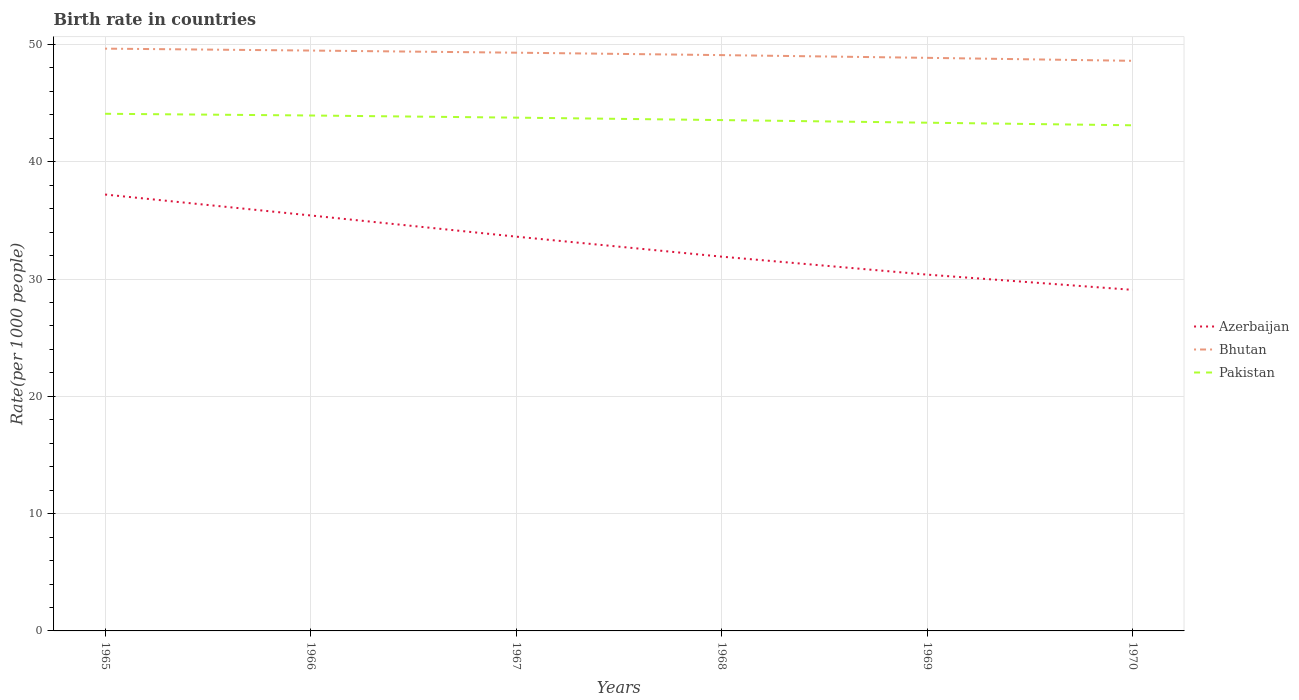Does the line corresponding to Azerbaijan intersect with the line corresponding to Bhutan?
Offer a terse response. No. Is the number of lines equal to the number of legend labels?
Make the answer very short. Yes. Across all years, what is the maximum birth rate in Bhutan?
Offer a very short reply. 48.6. What is the total birth rate in Pakistan in the graph?
Your answer should be very brief. 0.76. What is the difference between the highest and the second highest birth rate in Pakistan?
Ensure brevity in your answer.  0.98. Is the birth rate in Azerbaijan strictly greater than the birth rate in Pakistan over the years?
Provide a succinct answer. Yes. How many lines are there?
Your response must be concise. 3. Are the values on the major ticks of Y-axis written in scientific E-notation?
Your answer should be compact. No. Where does the legend appear in the graph?
Keep it short and to the point. Center right. How many legend labels are there?
Your answer should be very brief. 3. How are the legend labels stacked?
Your response must be concise. Vertical. What is the title of the graph?
Offer a very short reply. Birth rate in countries. Does "Small states" appear as one of the legend labels in the graph?
Provide a short and direct response. No. What is the label or title of the Y-axis?
Offer a very short reply. Rate(per 1000 people). What is the Rate(per 1000 people) in Azerbaijan in 1965?
Your answer should be compact. 37.2. What is the Rate(per 1000 people) of Bhutan in 1965?
Ensure brevity in your answer.  49.64. What is the Rate(per 1000 people) in Pakistan in 1965?
Your answer should be compact. 44.09. What is the Rate(per 1000 people) in Azerbaijan in 1966?
Give a very brief answer. 35.42. What is the Rate(per 1000 people) in Bhutan in 1966?
Your response must be concise. 49.48. What is the Rate(per 1000 people) of Pakistan in 1966?
Provide a succinct answer. 43.94. What is the Rate(per 1000 people) of Azerbaijan in 1967?
Provide a short and direct response. 33.62. What is the Rate(per 1000 people) of Bhutan in 1967?
Make the answer very short. 49.3. What is the Rate(per 1000 people) of Pakistan in 1967?
Your answer should be very brief. 43.76. What is the Rate(per 1000 people) of Azerbaijan in 1968?
Your response must be concise. 31.91. What is the Rate(per 1000 people) of Bhutan in 1968?
Provide a succinct answer. 49.09. What is the Rate(per 1000 people) in Pakistan in 1968?
Give a very brief answer. 43.55. What is the Rate(per 1000 people) of Azerbaijan in 1969?
Your answer should be very brief. 30.38. What is the Rate(per 1000 people) in Bhutan in 1969?
Provide a short and direct response. 48.86. What is the Rate(per 1000 people) in Pakistan in 1969?
Give a very brief answer. 43.33. What is the Rate(per 1000 people) of Azerbaijan in 1970?
Your answer should be compact. 29.08. What is the Rate(per 1000 people) in Bhutan in 1970?
Make the answer very short. 48.6. What is the Rate(per 1000 people) of Pakistan in 1970?
Offer a terse response. 43.11. Across all years, what is the maximum Rate(per 1000 people) in Azerbaijan?
Give a very brief answer. 37.2. Across all years, what is the maximum Rate(per 1000 people) in Bhutan?
Keep it short and to the point. 49.64. Across all years, what is the maximum Rate(per 1000 people) of Pakistan?
Your response must be concise. 44.09. Across all years, what is the minimum Rate(per 1000 people) in Azerbaijan?
Offer a terse response. 29.08. Across all years, what is the minimum Rate(per 1000 people) of Bhutan?
Ensure brevity in your answer.  48.6. Across all years, what is the minimum Rate(per 1000 people) in Pakistan?
Provide a succinct answer. 43.11. What is the total Rate(per 1000 people) in Azerbaijan in the graph?
Provide a succinct answer. 197.6. What is the total Rate(per 1000 people) of Bhutan in the graph?
Offer a terse response. 294.98. What is the total Rate(per 1000 people) of Pakistan in the graph?
Make the answer very short. 261.78. What is the difference between the Rate(per 1000 people) of Azerbaijan in 1965 and that in 1966?
Offer a very short reply. 1.78. What is the difference between the Rate(per 1000 people) in Bhutan in 1965 and that in 1966?
Ensure brevity in your answer.  0.16. What is the difference between the Rate(per 1000 people) of Pakistan in 1965 and that in 1966?
Your answer should be very brief. 0.15. What is the difference between the Rate(per 1000 people) in Azerbaijan in 1965 and that in 1967?
Offer a terse response. 3.59. What is the difference between the Rate(per 1000 people) in Bhutan in 1965 and that in 1967?
Offer a very short reply. 0.34. What is the difference between the Rate(per 1000 people) in Pakistan in 1965 and that in 1967?
Offer a very short reply. 0.33. What is the difference between the Rate(per 1000 people) of Azerbaijan in 1965 and that in 1968?
Provide a succinct answer. 5.3. What is the difference between the Rate(per 1000 people) in Bhutan in 1965 and that in 1968?
Make the answer very short. 0.55. What is the difference between the Rate(per 1000 people) of Pakistan in 1965 and that in 1968?
Give a very brief answer. 0.54. What is the difference between the Rate(per 1000 people) in Azerbaijan in 1965 and that in 1969?
Ensure brevity in your answer.  6.83. What is the difference between the Rate(per 1000 people) of Bhutan in 1965 and that in 1969?
Provide a short and direct response. 0.78. What is the difference between the Rate(per 1000 people) of Pakistan in 1965 and that in 1969?
Offer a terse response. 0.76. What is the difference between the Rate(per 1000 people) in Azerbaijan in 1965 and that in 1970?
Provide a succinct answer. 8.13. What is the difference between the Rate(per 1000 people) in Bhutan in 1965 and that in 1970?
Offer a terse response. 1.04. What is the difference between the Rate(per 1000 people) in Pakistan in 1965 and that in 1970?
Ensure brevity in your answer.  0.98. What is the difference between the Rate(per 1000 people) of Azerbaijan in 1966 and that in 1967?
Keep it short and to the point. 1.81. What is the difference between the Rate(per 1000 people) of Bhutan in 1966 and that in 1967?
Your answer should be very brief. 0.18. What is the difference between the Rate(per 1000 people) of Pakistan in 1966 and that in 1967?
Offer a very short reply. 0.18. What is the difference between the Rate(per 1000 people) in Azerbaijan in 1966 and that in 1968?
Provide a short and direct response. 3.51. What is the difference between the Rate(per 1000 people) of Bhutan in 1966 and that in 1968?
Your answer should be very brief. 0.39. What is the difference between the Rate(per 1000 people) in Pakistan in 1966 and that in 1968?
Keep it short and to the point. 0.39. What is the difference between the Rate(per 1000 people) in Azerbaijan in 1966 and that in 1969?
Your response must be concise. 5.04. What is the difference between the Rate(per 1000 people) of Bhutan in 1966 and that in 1969?
Make the answer very short. 0.62. What is the difference between the Rate(per 1000 people) of Pakistan in 1966 and that in 1969?
Provide a succinct answer. 0.61. What is the difference between the Rate(per 1000 people) in Azerbaijan in 1966 and that in 1970?
Offer a terse response. 6.34. What is the difference between the Rate(per 1000 people) in Bhutan in 1966 and that in 1970?
Your answer should be compact. 0.88. What is the difference between the Rate(per 1000 people) in Pakistan in 1966 and that in 1970?
Offer a terse response. 0.83. What is the difference between the Rate(per 1000 people) in Azerbaijan in 1967 and that in 1968?
Your response must be concise. 1.71. What is the difference between the Rate(per 1000 people) of Bhutan in 1967 and that in 1968?
Ensure brevity in your answer.  0.21. What is the difference between the Rate(per 1000 people) of Pakistan in 1967 and that in 1968?
Ensure brevity in your answer.  0.21. What is the difference between the Rate(per 1000 people) in Azerbaijan in 1967 and that in 1969?
Offer a terse response. 3.24. What is the difference between the Rate(per 1000 people) of Bhutan in 1967 and that in 1969?
Ensure brevity in your answer.  0.44. What is the difference between the Rate(per 1000 people) in Pakistan in 1967 and that in 1969?
Ensure brevity in your answer.  0.43. What is the difference between the Rate(per 1000 people) in Azerbaijan in 1967 and that in 1970?
Offer a terse response. 4.54. What is the difference between the Rate(per 1000 people) of Bhutan in 1967 and that in 1970?
Offer a terse response. 0.69. What is the difference between the Rate(per 1000 people) in Pakistan in 1967 and that in 1970?
Your answer should be compact. 0.65. What is the difference between the Rate(per 1000 people) of Azerbaijan in 1968 and that in 1969?
Give a very brief answer. 1.53. What is the difference between the Rate(per 1000 people) in Bhutan in 1968 and that in 1969?
Give a very brief answer. 0.23. What is the difference between the Rate(per 1000 people) of Pakistan in 1968 and that in 1969?
Offer a terse response. 0.22. What is the difference between the Rate(per 1000 people) in Azerbaijan in 1968 and that in 1970?
Make the answer very short. 2.83. What is the difference between the Rate(per 1000 people) of Bhutan in 1968 and that in 1970?
Make the answer very short. 0.49. What is the difference between the Rate(per 1000 people) in Pakistan in 1968 and that in 1970?
Provide a succinct answer. 0.44. What is the difference between the Rate(per 1000 people) of Azerbaijan in 1969 and that in 1970?
Your response must be concise. 1.3. What is the difference between the Rate(per 1000 people) of Bhutan in 1969 and that in 1970?
Keep it short and to the point. 0.26. What is the difference between the Rate(per 1000 people) in Pakistan in 1969 and that in 1970?
Make the answer very short. 0.22. What is the difference between the Rate(per 1000 people) of Azerbaijan in 1965 and the Rate(per 1000 people) of Bhutan in 1966?
Provide a succinct answer. -12.28. What is the difference between the Rate(per 1000 people) of Azerbaijan in 1965 and the Rate(per 1000 people) of Pakistan in 1966?
Your answer should be compact. -6.74. What is the difference between the Rate(per 1000 people) in Bhutan in 1965 and the Rate(per 1000 people) in Pakistan in 1966?
Offer a very short reply. 5.7. What is the difference between the Rate(per 1000 people) of Azerbaijan in 1965 and the Rate(per 1000 people) of Bhutan in 1967?
Offer a terse response. -12.09. What is the difference between the Rate(per 1000 people) of Azerbaijan in 1965 and the Rate(per 1000 people) of Pakistan in 1967?
Keep it short and to the point. -6.55. What is the difference between the Rate(per 1000 people) in Bhutan in 1965 and the Rate(per 1000 people) in Pakistan in 1967?
Offer a very short reply. 5.88. What is the difference between the Rate(per 1000 people) of Azerbaijan in 1965 and the Rate(per 1000 people) of Bhutan in 1968?
Your answer should be very brief. -11.89. What is the difference between the Rate(per 1000 people) in Azerbaijan in 1965 and the Rate(per 1000 people) in Pakistan in 1968?
Offer a very short reply. -6.35. What is the difference between the Rate(per 1000 people) in Bhutan in 1965 and the Rate(per 1000 people) in Pakistan in 1968?
Provide a succinct answer. 6.09. What is the difference between the Rate(per 1000 people) in Azerbaijan in 1965 and the Rate(per 1000 people) in Bhutan in 1969?
Your answer should be compact. -11.65. What is the difference between the Rate(per 1000 people) of Azerbaijan in 1965 and the Rate(per 1000 people) of Pakistan in 1969?
Your answer should be very brief. -6.12. What is the difference between the Rate(per 1000 people) of Bhutan in 1965 and the Rate(per 1000 people) of Pakistan in 1969?
Your answer should be compact. 6.31. What is the difference between the Rate(per 1000 people) in Azerbaijan in 1965 and the Rate(per 1000 people) in Bhutan in 1970?
Ensure brevity in your answer.  -11.4. What is the difference between the Rate(per 1000 people) in Azerbaijan in 1965 and the Rate(per 1000 people) in Pakistan in 1970?
Your answer should be very brief. -5.9. What is the difference between the Rate(per 1000 people) of Bhutan in 1965 and the Rate(per 1000 people) of Pakistan in 1970?
Provide a succinct answer. 6.54. What is the difference between the Rate(per 1000 people) in Azerbaijan in 1966 and the Rate(per 1000 people) in Bhutan in 1967?
Ensure brevity in your answer.  -13.88. What is the difference between the Rate(per 1000 people) of Azerbaijan in 1966 and the Rate(per 1000 people) of Pakistan in 1967?
Offer a very short reply. -8.34. What is the difference between the Rate(per 1000 people) in Bhutan in 1966 and the Rate(per 1000 people) in Pakistan in 1967?
Provide a short and direct response. 5.72. What is the difference between the Rate(per 1000 people) of Azerbaijan in 1966 and the Rate(per 1000 people) of Bhutan in 1968?
Ensure brevity in your answer.  -13.67. What is the difference between the Rate(per 1000 people) in Azerbaijan in 1966 and the Rate(per 1000 people) in Pakistan in 1968?
Provide a short and direct response. -8.13. What is the difference between the Rate(per 1000 people) in Bhutan in 1966 and the Rate(per 1000 people) in Pakistan in 1968?
Give a very brief answer. 5.93. What is the difference between the Rate(per 1000 people) in Azerbaijan in 1966 and the Rate(per 1000 people) in Bhutan in 1969?
Keep it short and to the point. -13.44. What is the difference between the Rate(per 1000 people) of Azerbaijan in 1966 and the Rate(per 1000 people) of Pakistan in 1969?
Ensure brevity in your answer.  -7.91. What is the difference between the Rate(per 1000 people) in Bhutan in 1966 and the Rate(per 1000 people) in Pakistan in 1969?
Provide a succinct answer. 6.15. What is the difference between the Rate(per 1000 people) in Azerbaijan in 1966 and the Rate(per 1000 people) in Bhutan in 1970?
Keep it short and to the point. -13.18. What is the difference between the Rate(per 1000 people) of Azerbaijan in 1966 and the Rate(per 1000 people) of Pakistan in 1970?
Provide a short and direct response. -7.69. What is the difference between the Rate(per 1000 people) in Bhutan in 1966 and the Rate(per 1000 people) in Pakistan in 1970?
Ensure brevity in your answer.  6.37. What is the difference between the Rate(per 1000 people) of Azerbaijan in 1967 and the Rate(per 1000 people) of Bhutan in 1968?
Ensure brevity in your answer.  -15.48. What is the difference between the Rate(per 1000 people) in Azerbaijan in 1967 and the Rate(per 1000 people) in Pakistan in 1968?
Ensure brevity in your answer.  -9.94. What is the difference between the Rate(per 1000 people) in Bhutan in 1967 and the Rate(per 1000 people) in Pakistan in 1968?
Offer a very short reply. 5.75. What is the difference between the Rate(per 1000 people) of Azerbaijan in 1967 and the Rate(per 1000 people) of Bhutan in 1969?
Ensure brevity in your answer.  -15.24. What is the difference between the Rate(per 1000 people) in Azerbaijan in 1967 and the Rate(per 1000 people) in Pakistan in 1969?
Offer a terse response. -9.71. What is the difference between the Rate(per 1000 people) in Bhutan in 1967 and the Rate(per 1000 people) in Pakistan in 1969?
Make the answer very short. 5.97. What is the difference between the Rate(per 1000 people) in Azerbaijan in 1967 and the Rate(per 1000 people) in Bhutan in 1970?
Your response must be concise. -14.99. What is the difference between the Rate(per 1000 people) in Azerbaijan in 1967 and the Rate(per 1000 people) in Pakistan in 1970?
Provide a succinct answer. -9.49. What is the difference between the Rate(per 1000 people) of Bhutan in 1967 and the Rate(per 1000 people) of Pakistan in 1970?
Give a very brief answer. 6.19. What is the difference between the Rate(per 1000 people) in Azerbaijan in 1968 and the Rate(per 1000 people) in Bhutan in 1969?
Give a very brief answer. -16.95. What is the difference between the Rate(per 1000 people) in Azerbaijan in 1968 and the Rate(per 1000 people) in Pakistan in 1969?
Provide a succinct answer. -11.42. What is the difference between the Rate(per 1000 people) in Bhutan in 1968 and the Rate(per 1000 people) in Pakistan in 1969?
Your answer should be compact. 5.76. What is the difference between the Rate(per 1000 people) of Azerbaijan in 1968 and the Rate(per 1000 people) of Bhutan in 1970?
Make the answer very short. -16.7. What is the difference between the Rate(per 1000 people) of Bhutan in 1968 and the Rate(per 1000 people) of Pakistan in 1970?
Provide a succinct answer. 5.98. What is the difference between the Rate(per 1000 people) in Azerbaijan in 1969 and the Rate(per 1000 people) in Bhutan in 1970?
Your answer should be very brief. -18.23. What is the difference between the Rate(per 1000 people) in Azerbaijan in 1969 and the Rate(per 1000 people) in Pakistan in 1970?
Your answer should be very brief. -12.73. What is the difference between the Rate(per 1000 people) of Bhutan in 1969 and the Rate(per 1000 people) of Pakistan in 1970?
Give a very brief answer. 5.75. What is the average Rate(per 1000 people) in Azerbaijan per year?
Give a very brief answer. 32.93. What is the average Rate(per 1000 people) of Bhutan per year?
Provide a short and direct response. 49.16. What is the average Rate(per 1000 people) of Pakistan per year?
Your answer should be compact. 43.63. In the year 1965, what is the difference between the Rate(per 1000 people) in Azerbaijan and Rate(per 1000 people) in Bhutan?
Provide a succinct answer. -12.44. In the year 1965, what is the difference between the Rate(per 1000 people) of Azerbaijan and Rate(per 1000 people) of Pakistan?
Offer a very short reply. -6.88. In the year 1965, what is the difference between the Rate(per 1000 people) in Bhutan and Rate(per 1000 people) in Pakistan?
Give a very brief answer. 5.55. In the year 1966, what is the difference between the Rate(per 1000 people) of Azerbaijan and Rate(per 1000 people) of Bhutan?
Offer a very short reply. -14.06. In the year 1966, what is the difference between the Rate(per 1000 people) in Azerbaijan and Rate(per 1000 people) in Pakistan?
Keep it short and to the point. -8.52. In the year 1966, what is the difference between the Rate(per 1000 people) of Bhutan and Rate(per 1000 people) of Pakistan?
Make the answer very short. 5.54. In the year 1967, what is the difference between the Rate(per 1000 people) of Azerbaijan and Rate(per 1000 people) of Bhutan?
Your answer should be very brief. -15.68. In the year 1967, what is the difference between the Rate(per 1000 people) in Azerbaijan and Rate(per 1000 people) in Pakistan?
Provide a succinct answer. -10.14. In the year 1967, what is the difference between the Rate(per 1000 people) of Bhutan and Rate(per 1000 people) of Pakistan?
Offer a terse response. 5.54. In the year 1968, what is the difference between the Rate(per 1000 people) in Azerbaijan and Rate(per 1000 people) in Bhutan?
Give a very brief answer. -17.18. In the year 1968, what is the difference between the Rate(per 1000 people) in Azerbaijan and Rate(per 1000 people) in Pakistan?
Your answer should be compact. -11.64. In the year 1968, what is the difference between the Rate(per 1000 people) in Bhutan and Rate(per 1000 people) in Pakistan?
Make the answer very short. 5.54. In the year 1969, what is the difference between the Rate(per 1000 people) in Azerbaijan and Rate(per 1000 people) in Bhutan?
Your answer should be compact. -18.48. In the year 1969, what is the difference between the Rate(per 1000 people) of Azerbaijan and Rate(per 1000 people) of Pakistan?
Make the answer very short. -12.95. In the year 1969, what is the difference between the Rate(per 1000 people) of Bhutan and Rate(per 1000 people) of Pakistan?
Ensure brevity in your answer.  5.53. In the year 1970, what is the difference between the Rate(per 1000 people) in Azerbaijan and Rate(per 1000 people) in Bhutan?
Ensure brevity in your answer.  -19.53. In the year 1970, what is the difference between the Rate(per 1000 people) in Azerbaijan and Rate(per 1000 people) in Pakistan?
Offer a terse response. -14.03. In the year 1970, what is the difference between the Rate(per 1000 people) of Bhutan and Rate(per 1000 people) of Pakistan?
Make the answer very short. 5.5. What is the ratio of the Rate(per 1000 people) in Azerbaijan in 1965 to that in 1966?
Your answer should be very brief. 1.05. What is the ratio of the Rate(per 1000 people) of Bhutan in 1965 to that in 1966?
Offer a terse response. 1. What is the ratio of the Rate(per 1000 people) of Pakistan in 1965 to that in 1966?
Provide a succinct answer. 1. What is the ratio of the Rate(per 1000 people) in Azerbaijan in 1965 to that in 1967?
Ensure brevity in your answer.  1.11. What is the ratio of the Rate(per 1000 people) of Pakistan in 1965 to that in 1967?
Keep it short and to the point. 1.01. What is the ratio of the Rate(per 1000 people) of Azerbaijan in 1965 to that in 1968?
Your answer should be very brief. 1.17. What is the ratio of the Rate(per 1000 people) of Bhutan in 1965 to that in 1968?
Keep it short and to the point. 1.01. What is the ratio of the Rate(per 1000 people) in Pakistan in 1965 to that in 1968?
Your answer should be very brief. 1.01. What is the ratio of the Rate(per 1000 people) in Azerbaijan in 1965 to that in 1969?
Provide a succinct answer. 1.22. What is the ratio of the Rate(per 1000 people) in Bhutan in 1965 to that in 1969?
Keep it short and to the point. 1.02. What is the ratio of the Rate(per 1000 people) in Pakistan in 1965 to that in 1969?
Offer a very short reply. 1.02. What is the ratio of the Rate(per 1000 people) of Azerbaijan in 1965 to that in 1970?
Make the answer very short. 1.28. What is the ratio of the Rate(per 1000 people) of Bhutan in 1965 to that in 1970?
Give a very brief answer. 1.02. What is the ratio of the Rate(per 1000 people) in Pakistan in 1965 to that in 1970?
Provide a succinct answer. 1.02. What is the ratio of the Rate(per 1000 people) of Azerbaijan in 1966 to that in 1967?
Ensure brevity in your answer.  1.05. What is the ratio of the Rate(per 1000 people) in Bhutan in 1966 to that in 1967?
Offer a terse response. 1. What is the ratio of the Rate(per 1000 people) of Pakistan in 1966 to that in 1967?
Your response must be concise. 1. What is the ratio of the Rate(per 1000 people) in Azerbaijan in 1966 to that in 1968?
Provide a short and direct response. 1.11. What is the ratio of the Rate(per 1000 people) in Bhutan in 1966 to that in 1968?
Make the answer very short. 1.01. What is the ratio of the Rate(per 1000 people) of Pakistan in 1966 to that in 1968?
Offer a terse response. 1.01. What is the ratio of the Rate(per 1000 people) in Azerbaijan in 1966 to that in 1969?
Keep it short and to the point. 1.17. What is the ratio of the Rate(per 1000 people) in Bhutan in 1966 to that in 1969?
Ensure brevity in your answer.  1.01. What is the ratio of the Rate(per 1000 people) of Pakistan in 1966 to that in 1969?
Your answer should be very brief. 1.01. What is the ratio of the Rate(per 1000 people) in Azerbaijan in 1966 to that in 1970?
Offer a very short reply. 1.22. What is the ratio of the Rate(per 1000 people) of Pakistan in 1966 to that in 1970?
Provide a short and direct response. 1.02. What is the ratio of the Rate(per 1000 people) of Azerbaijan in 1967 to that in 1968?
Make the answer very short. 1.05. What is the ratio of the Rate(per 1000 people) of Bhutan in 1967 to that in 1968?
Your response must be concise. 1. What is the ratio of the Rate(per 1000 people) in Pakistan in 1967 to that in 1968?
Ensure brevity in your answer.  1. What is the ratio of the Rate(per 1000 people) in Azerbaijan in 1967 to that in 1969?
Ensure brevity in your answer.  1.11. What is the ratio of the Rate(per 1000 people) in Bhutan in 1967 to that in 1969?
Offer a terse response. 1.01. What is the ratio of the Rate(per 1000 people) of Pakistan in 1967 to that in 1969?
Ensure brevity in your answer.  1.01. What is the ratio of the Rate(per 1000 people) in Azerbaijan in 1967 to that in 1970?
Give a very brief answer. 1.16. What is the ratio of the Rate(per 1000 people) in Bhutan in 1967 to that in 1970?
Your response must be concise. 1.01. What is the ratio of the Rate(per 1000 people) of Pakistan in 1967 to that in 1970?
Your response must be concise. 1.02. What is the ratio of the Rate(per 1000 people) in Azerbaijan in 1968 to that in 1969?
Your answer should be very brief. 1.05. What is the ratio of the Rate(per 1000 people) of Bhutan in 1968 to that in 1969?
Ensure brevity in your answer.  1. What is the ratio of the Rate(per 1000 people) of Pakistan in 1968 to that in 1969?
Ensure brevity in your answer.  1.01. What is the ratio of the Rate(per 1000 people) of Azerbaijan in 1968 to that in 1970?
Your answer should be compact. 1.1. What is the ratio of the Rate(per 1000 people) in Bhutan in 1968 to that in 1970?
Give a very brief answer. 1.01. What is the ratio of the Rate(per 1000 people) in Pakistan in 1968 to that in 1970?
Make the answer very short. 1.01. What is the ratio of the Rate(per 1000 people) of Azerbaijan in 1969 to that in 1970?
Make the answer very short. 1.04. What is the ratio of the Rate(per 1000 people) in Bhutan in 1969 to that in 1970?
Offer a very short reply. 1.01. What is the difference between the highest and the second highest Rate(per 1000 people) of Azerbaijan?
Offer a terse response. 1.78. What is the difference between the highest and the second highest Rate(per 1000 people) in Bhutan?
Ensure brevity in your answer.  0.16. What is the difference between the highest and the second highest Rate(per 1000 people) of Pakistan?
Keep it short and to the point. 0.15. What is the difference between the highest and the lowest Rate(per 1000 people) in Azerbaijan?
Ensure brevity in your answer.  8.13. What is the difference between the highest and the lowest Rate(per 1000 people) of Bhutan?
Make the answer very short. 1.04. 